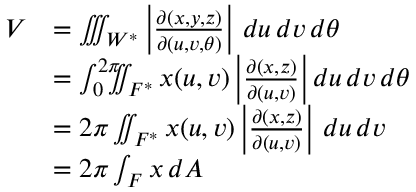<formula> <loc_0><loc_0><loc_500><loc_500>{ \begin{array} { r l } { V } & { = \iiint _ { W ^ { * } } \left | { \frac { \partial ( x , y , z ) } { \partial ( u , v , \theta ) } } \right | \, d u \, d v \, d \theta } \\ & { = \int _ { 0 } ^ { 2 \pi } \, \iint _ { F ^ { * } } x ( u , v ) \left | { \frac { \partial ( x , z ) } { \partial ( u , v ) } } \right | d u \, d v \, d \theta } \\ & { = 2 \pi \iint _ { F ^ { * } } x ( u , v ) \left | { \frac { \partial ( x , z ) } { \partial ( u , v ) } } \right | \, d u \, d v } \\ & { = 2 \pi \int _ { F } x \, d A } \end{array} }</formula> 